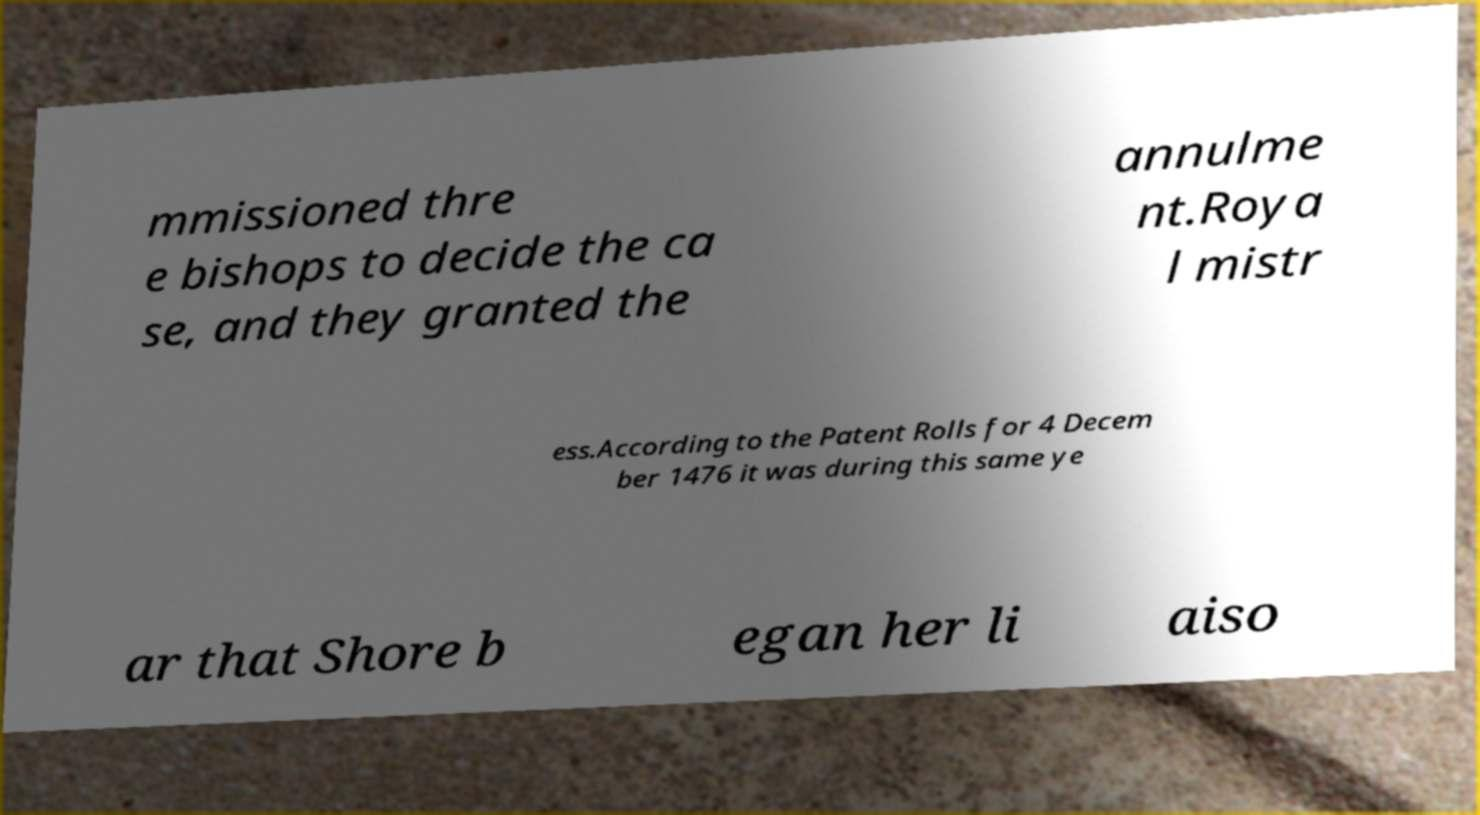For documentation purposes, I need the text within this image transcribed. Could you provide that? mmissioned thre e bishops to decide the ca se, and they granted the annulme nt.Roya l mistr ess.According to the Patent Rolls for 4 Decem ber 1476 it was during this same ye ar that Shore b egan her li aiso 